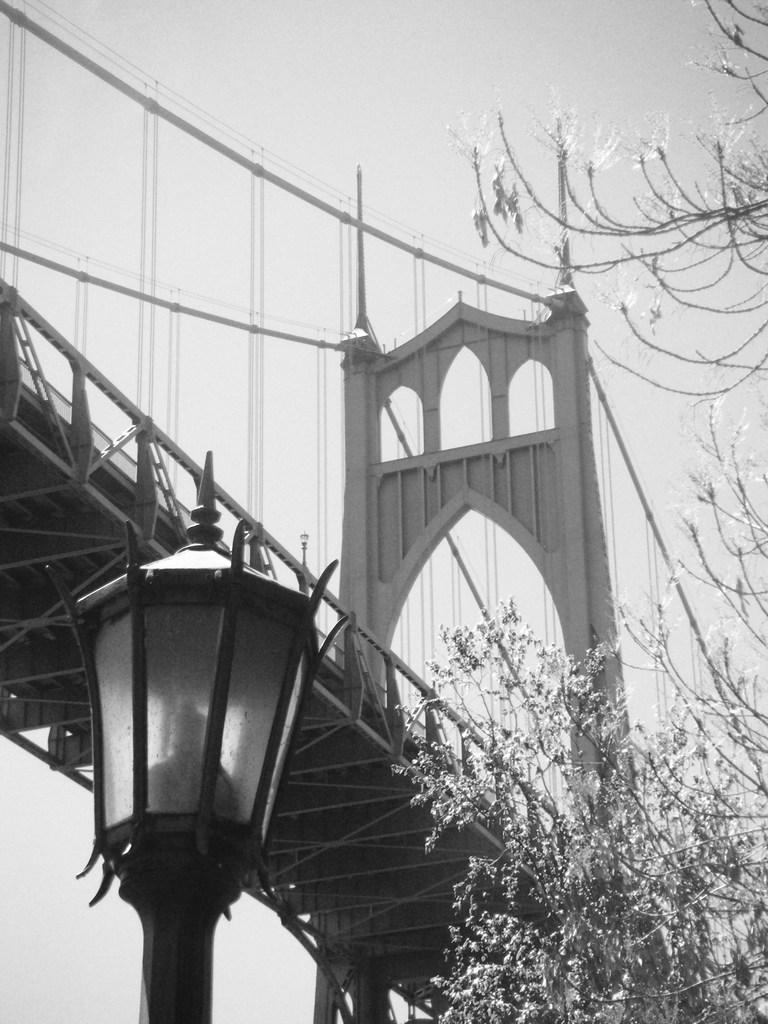What type of structure is depicted in the image? The image is of a suspension bridge. Can you describe the appearance of the bridge? The bridge appears to be old. What is located in the front bottom side of the image? There is a black color lamp post in the front bottom side of the image. What can be seen in the right corner of the image? There is a tree in the right corner of the image. What type of pipe is visible in the image? There is no pipe present in the image. Can you tell me how many keys are hanging from the tree in the image? There are no keys hanging from the tree in the image; it is a tree with leaves and branches. 